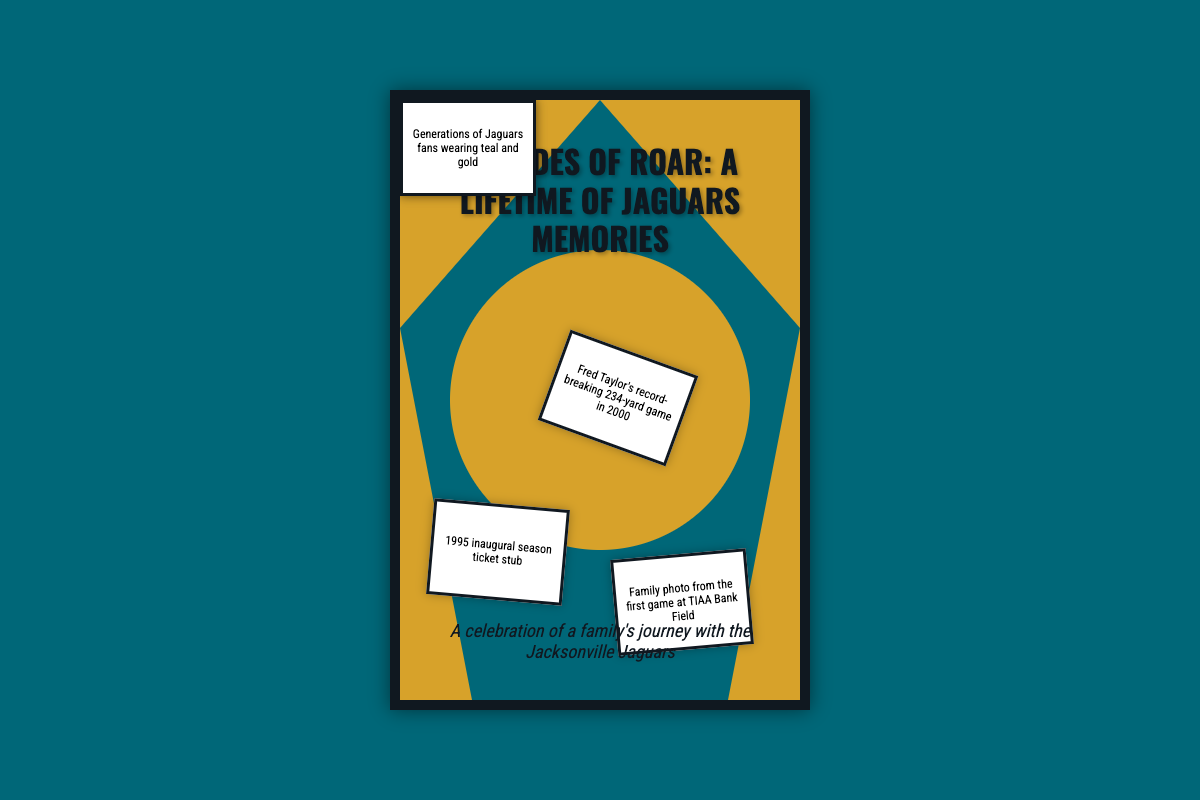What is the book title? The title is prominently displayed at the top of the cover in large text.
Answer: Decades of Roar: A Lifetime of Jaguars Memories What year did the Jaguars have their inaugural season? The ticket stub displayed represents the inaugural season, which is mentioned in the document.
Answer: 1995 Which player is highlighted for a record-breaking game? The item on the collage references a specific game and player who had a significant achievement.
Answer: Fred Taylor What significant game is referenced for the year 2017? The document specifies this game with its associated ticket in the collage.
Answer: AFC Championship game What color scheme represents the Jaguars? The background and elements on the cover reflect the team colors prominently featured throughout the design.
Answer: Teal and gold What does the subtitle suggest about the content? The subtitle describes the book's overarching theme, emphasizing family connections to the team.
Answer: A celebration of a family's journey with the Jacksonville Jaguars How many items are displayed in the collage? The document lists specific items that contribute to the visual story represented on the cover.
Answer: Five What type of document is this? The structure, visuals, and purpose of the content indicate its nature.
Answer: Book cover 